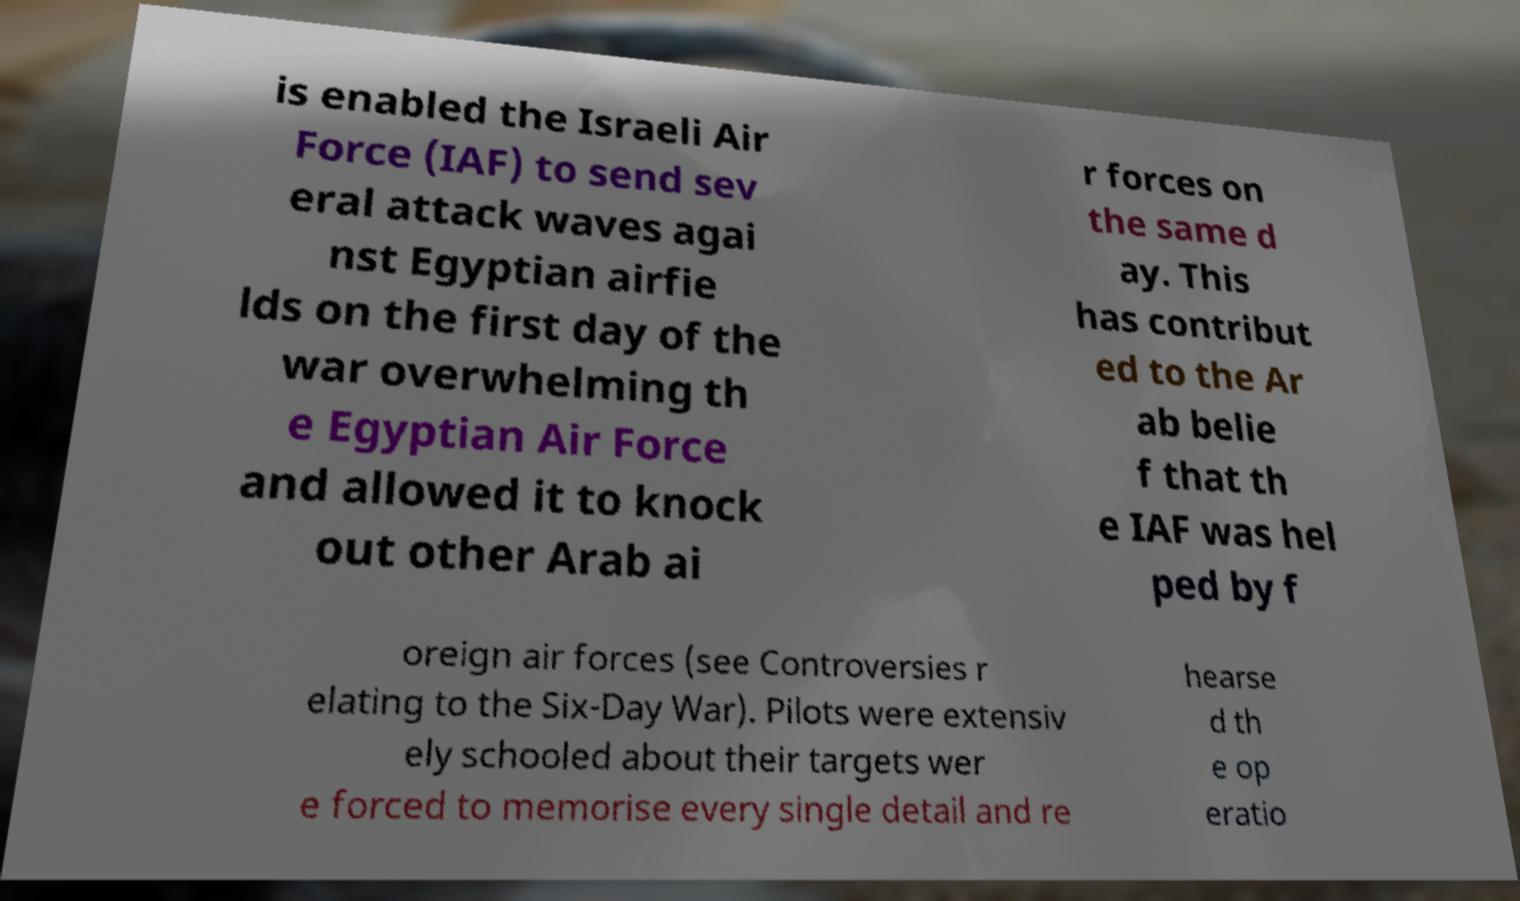I need the written content from this picture converted into text. Can you do that? is enabled the Israeli Air Force (IAF) to send sev eral attack waves agai nst Egyptian airfie lds on the first day of the war overwhelming th e Egyptian Air Force and allowed it to knock out other Arab ai r forces on the same d ay. This has contribut ed to the Ar ab belie f that th e IAF was hel ped by f oreign air forces (see Controversies r elating to the Six-Day War). Pilots were extensiv ely schooled about their targets wer e forced to memorise every single detail and re hearse d th e op eratio 